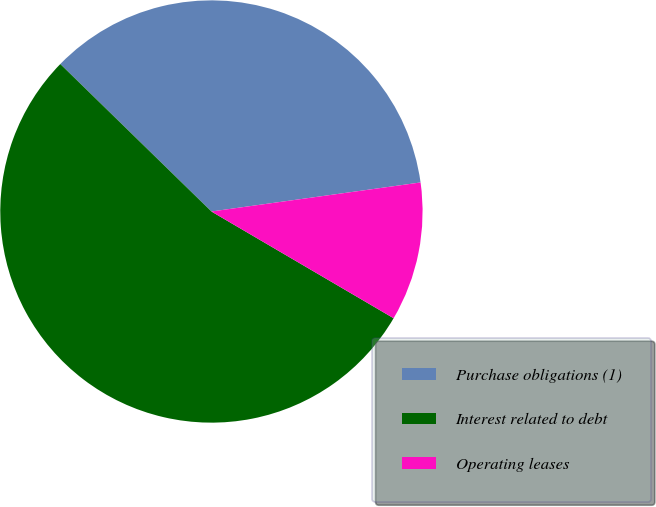Convert chart. <chart><loc_0><loc_0><loc_500><loc_500><pie_chart><fcel>Purchase obligations (1)<fcel>Interest related to debt<fcel>Operating leases<nl><fcel>35.5%<fcel>53.87%<fcel>10.63%<nl></chart> 